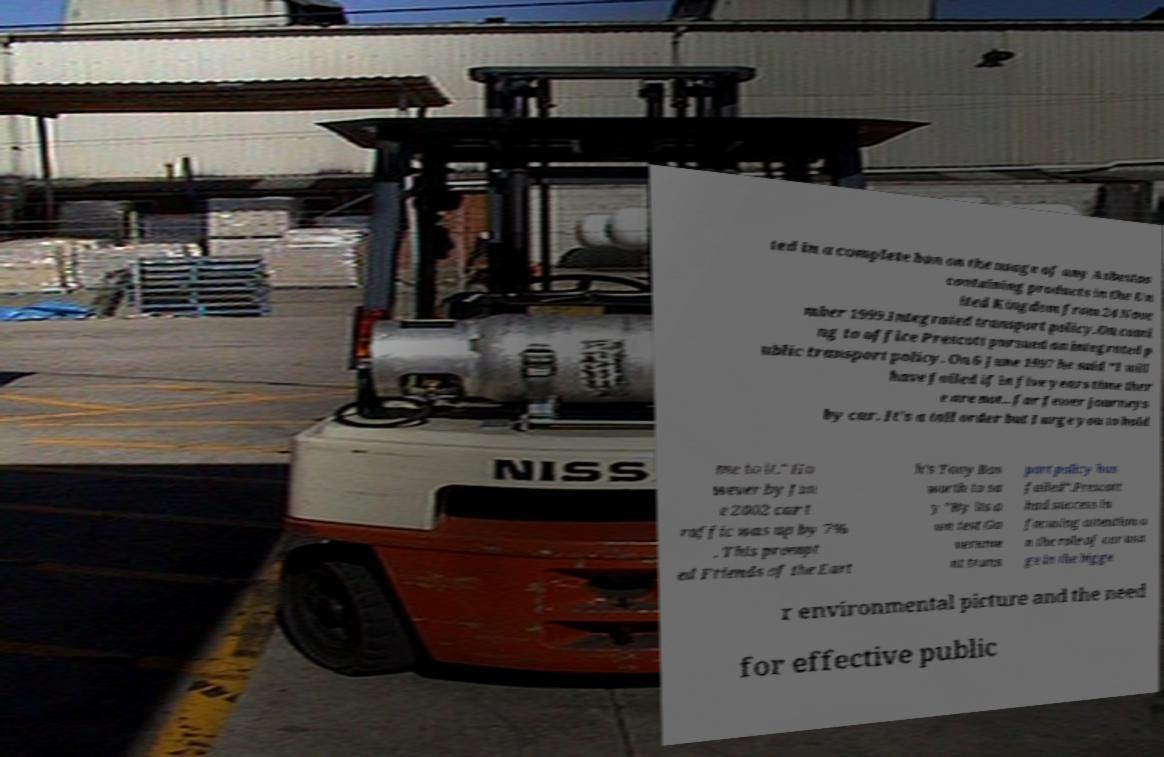Can you accurately transcribe the text from the provided image for me? ted in a complete ban on the usage of any Asbestos containing products in the Un ited Kingdom from 24 Nove mber 1999.Integrated transport policy.On comi ng to office Prescott pursued an integrated p ublic transport policy. On 6 June 1997 he said "I will have failed if in five years time ther e are not...far fewer journeys by car. It's a tall order but I urge you to hold me to it." Ho wever by Jun e 2002 car t raffic was up by 7% . This prompt ed Friends of the Eart h's Tony Bos worth to sa y "By its o wn test Go vernme nt trans port policy has failed".Prescott had success in focusing attention o n the role of car usa ge in the bigge r environmental picture and the need for effective public 